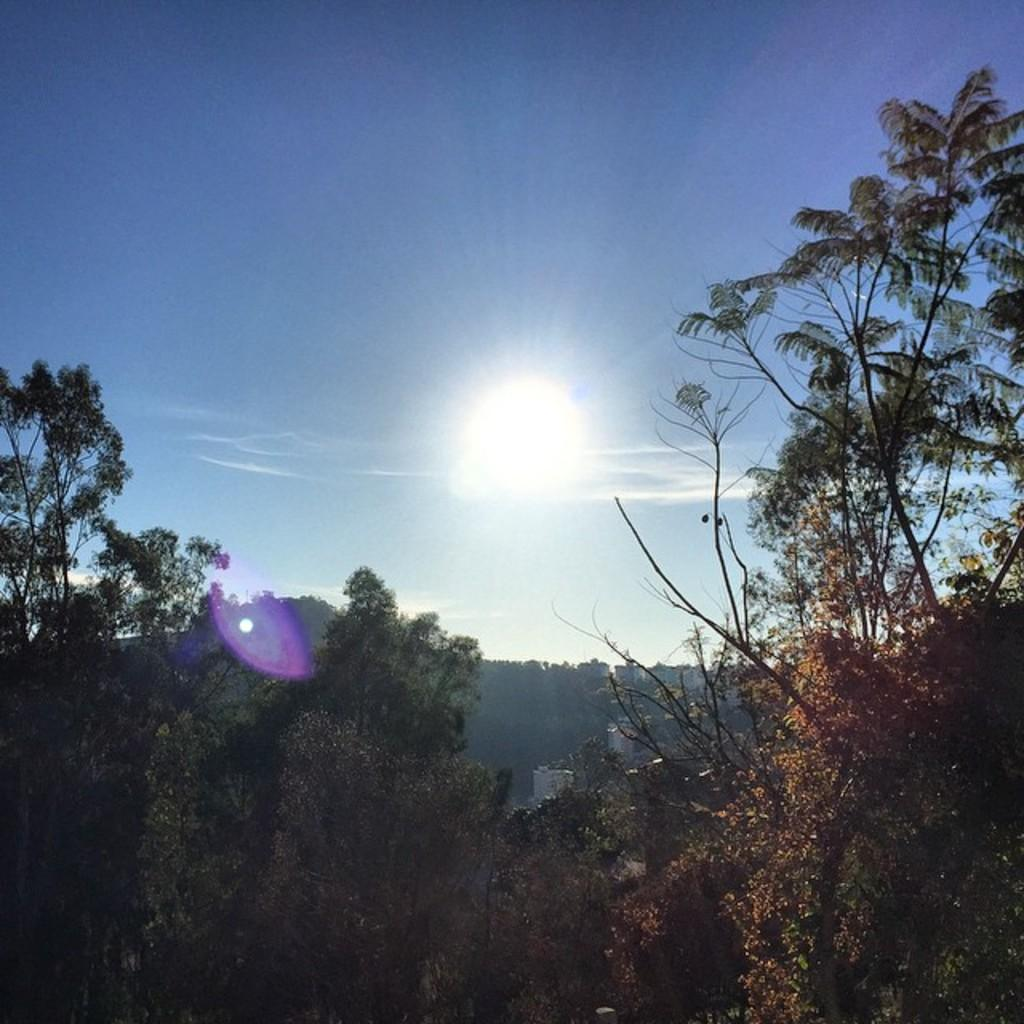What type of natural elements can be seen in the image? There are trees in the image. What type of man-made structures are present in the image? There are buildings in the image. What is the color of the sky in the image? The sky is blue in color. What celestial body is visible in the image? There is a sun visible in the image. What type of nerve can be seen in the image? There are no nerves present in the image; it features trees, buildings, a blue sky, and a sun. What type of division is depicted in the image? There is no division depicted in the image; it is a scene with trees, buildings, a blue sky, and a sun. 